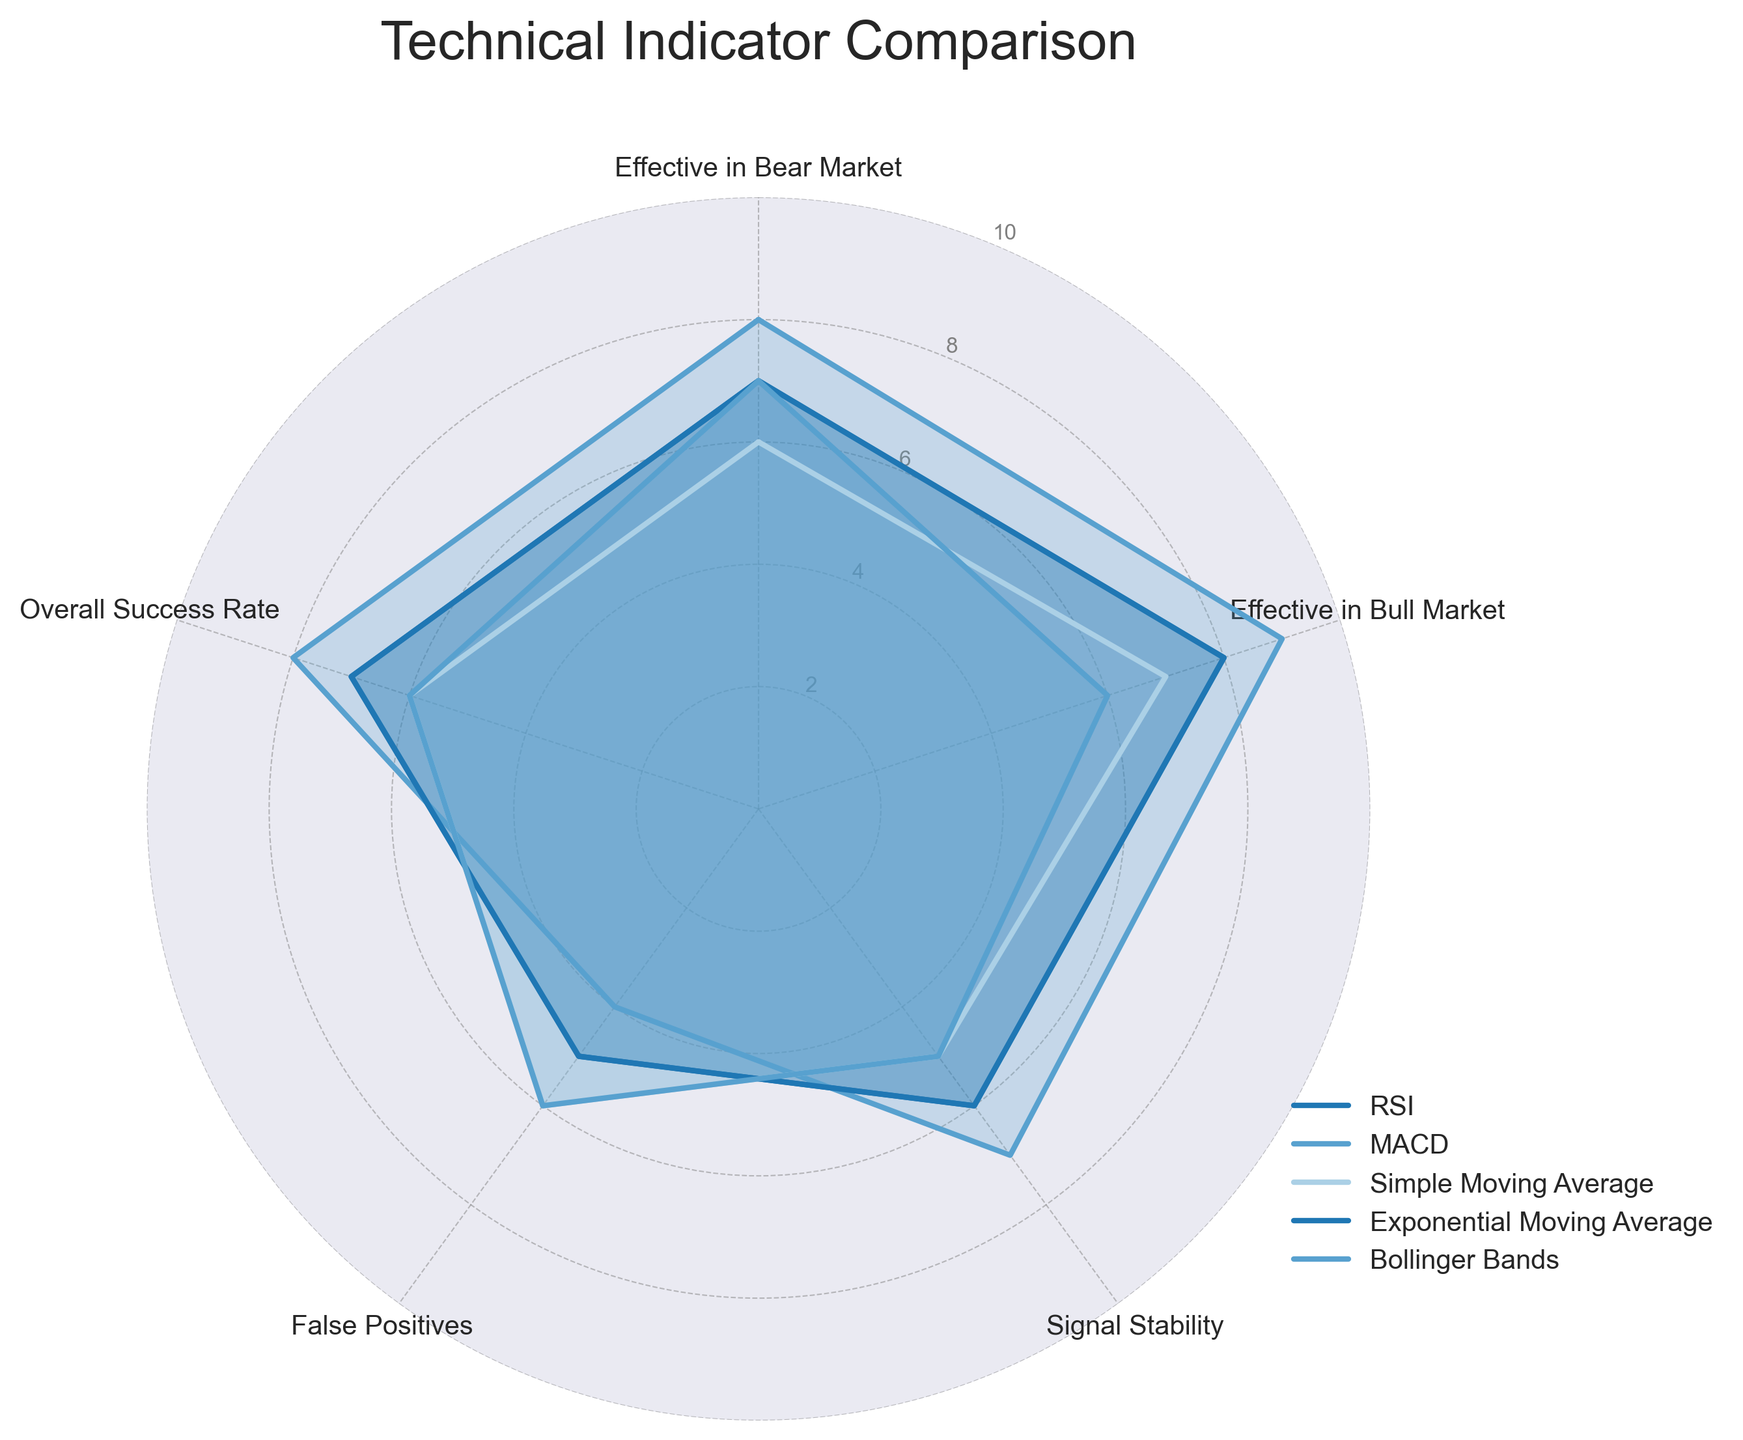What's the title of the chart? The title of the chart is displayed prominently at the top of the figure. It reads "Technical Indicator Comparison."
Answer: Technical Indicator Comparison Which indicator appears to be the most effective in both bear and bull markets? By looking at the "Effective in Bear Market" and "Effective in Bull Market" axes, we can see the lengths of the lines for each indicator. The MACD has the longest lines for both bear (8) and bull (9) markets.
Answer: MACD In which category do Simple Moving Average and Bollinger Bands have the same score? To find this, we need to look at the radius values on each axis for Simple Moving Average and Bollinger Bands. Both indicators have a score of 6 in the "False Positives" category.
Answer: False Positives How does RSI compare to Exponential Moving Average regarding the Overall Success Rate? By checking the "Overall Success Rate" axis, we see both the RSI and the Exponential Moving Average touch the same score value, which is 7.
Answer: Equal What is the average effectiveness of MACD in bear and bull markets? To calculate, add the effectiveness scores of MACD in bear (8) and bull (9) markets and divide by 2. (8 + 9) / 2 = 8.5.
Answer: 8.5 Which indicator has the highest Signal Stability? To determine this, find the longest line along the "Signal Stability" axis. MACD has the highest score here with a 7.
Answer: MACD Compare the False Positives of RSI and Simple Moving Average. Which one has fewer false positives? By examining their positions on the "False Positives" axis, RSI has a score of 5 whereas the Simple Moving Average has a score of 6. Thus, RSI has fewer false positives.
Answer: RSI Calculate the range of values for the "Effective in Bear Market" category. The minimum value in the "Effective in Bear Market" is 6 (Simple Moving Average) and the maximum value is 8 (MACD). The range is 8 - 6 = 2.
Answer: 2 